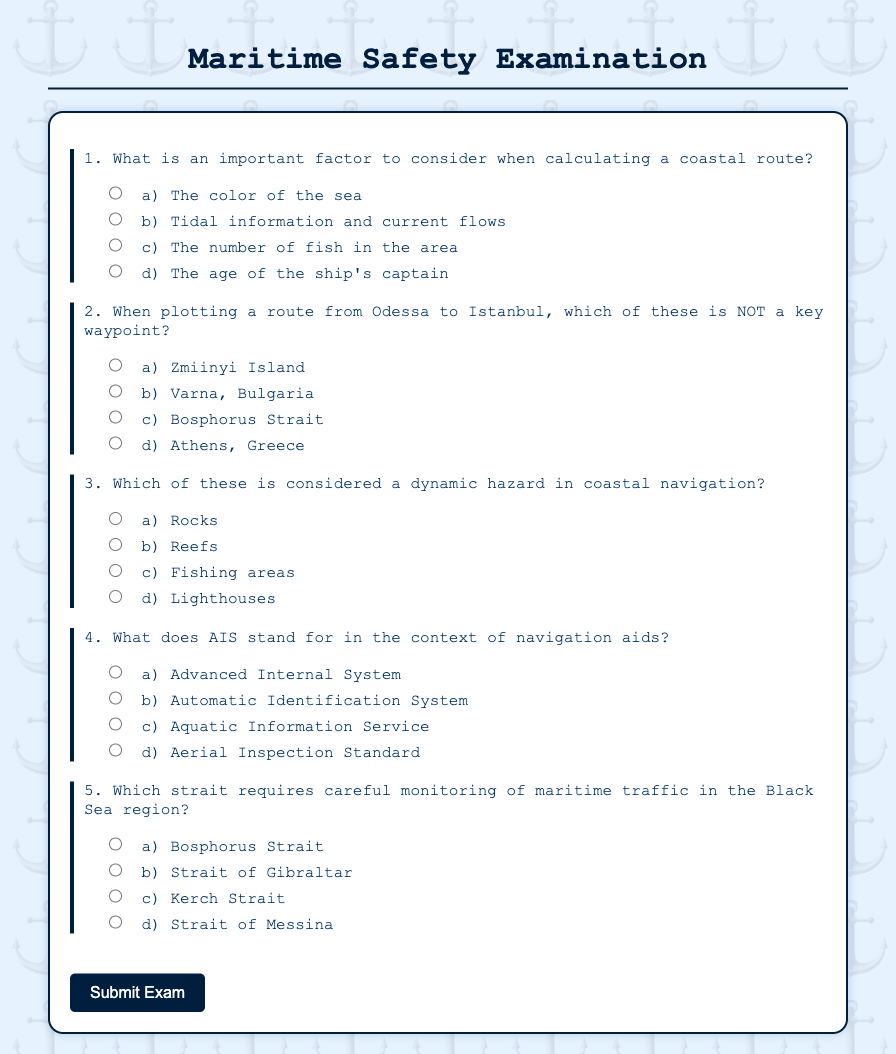What is the title of the document? The title is located in the head section of the code, which describes the content of the document.
Answer: Maritime Safety Examination How many questions are in the exam? The document contains multiple question sections defined in the form, each representing one question.
Answer: 5 What does AIS stand for? This abbreviation is explicitly given in one of the question options in the document.
Answer: Automatic Identification System Which strait is highlighted as requiring careful monitoring in the Black Sea region? This information is directly mentioned in one of the questions provided in the document.
Answer: Bosphorus Strait What type of navigation hazard is mentioned as a dynamic hazard? The answer to this question can be found in the options listed for questions about navigation hazards in the document.
Answer: Fishing areas What is the most southern waypoint listed for plotting a route from Odessa to Istanbul? This information requires comparing the options provided in the question regarding key waypoints.
Answer: Varna, Bulgaria 